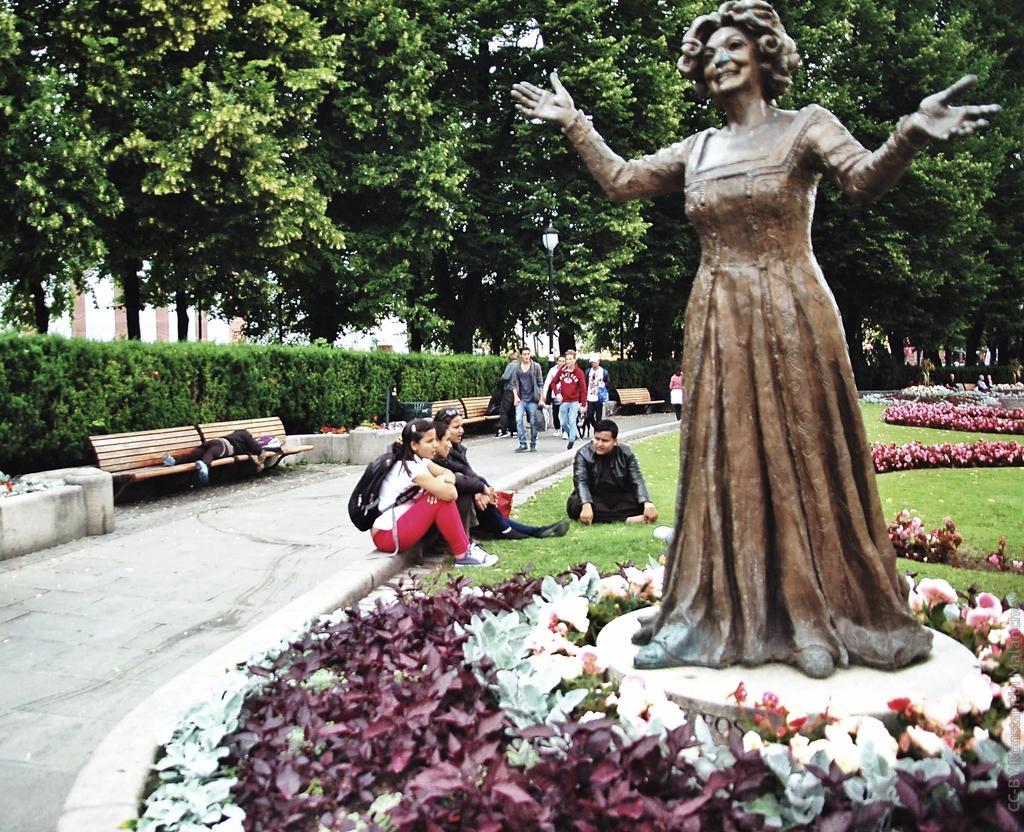Can you describe this image briefly? In this image we can see a lady statue. In the background we can see few people are sitting and walking on the ground. There are many trees in the background. 